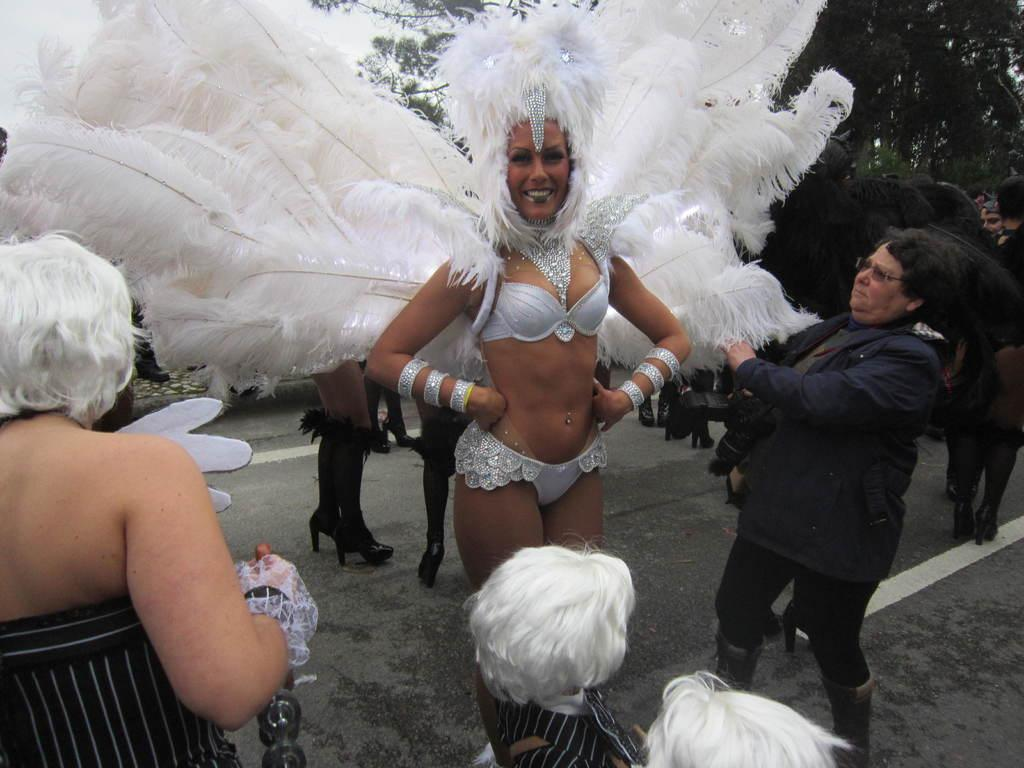How many people are in the image? There is a group of people in the image. Where are the people located in the image? The group of people is standing on a road. Can you describe the attire of one of the people in the group? A woman in the group is wearing a fancy dress. What is the facial expression of the woman in the fancy dress? The woman is smiling. What can be seen in the background of the image? There are trees and the sky visible in the background of the image. How many goldfish are swimming in the image? There are no goldfish present in the image; it features a group of people standing on a road. What type of treatment is the woman in the fancy dress receiving in the image? There is no indication in the image that the woman is receiving any treatment; she is simply standing with the group and smiling. 